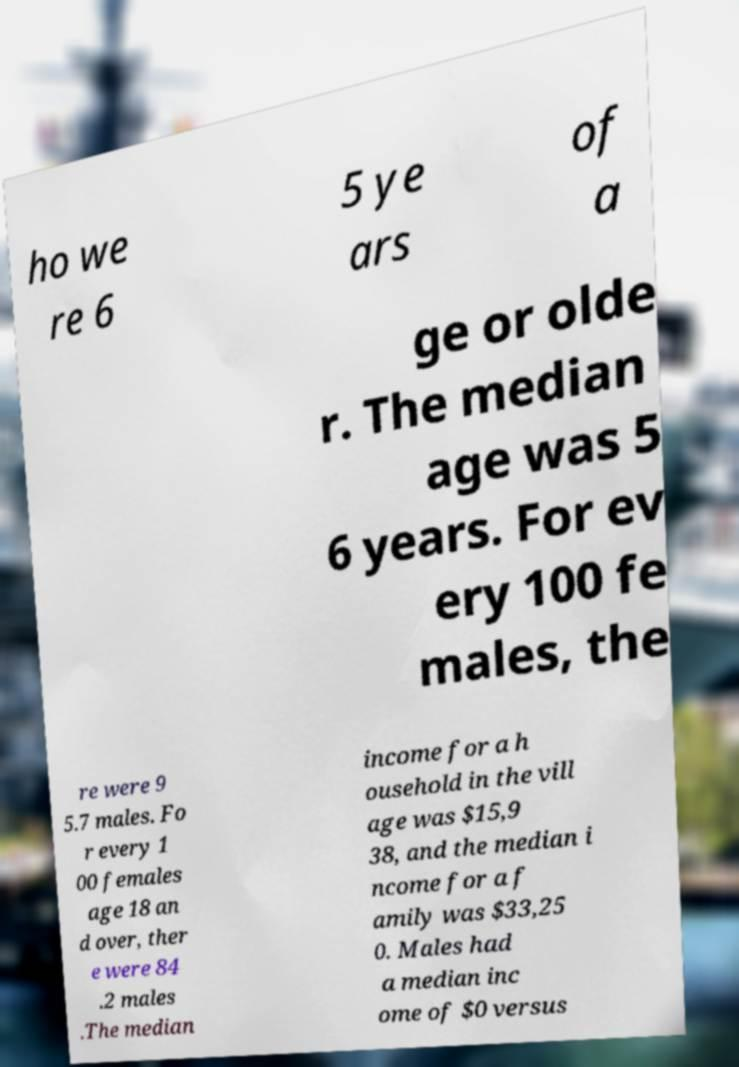Can you read and provide the text displayed in the image?This photo seems to have some interesting text. Can you extract and type it out for me? ho we re 6 5 ye ars of a ge or olde r. The median age was 5 6 years. For ev ery 100 fe males, the re were 9 5.7 males. Fo r every 1 00 females age 18 an d over, ther e were 84 .2 males .The median income for a h ousehold in the vill age was $15,9 38, and the median i ncome for a f amily was $33,25 0. Males had a median inc ome of $0 versus 